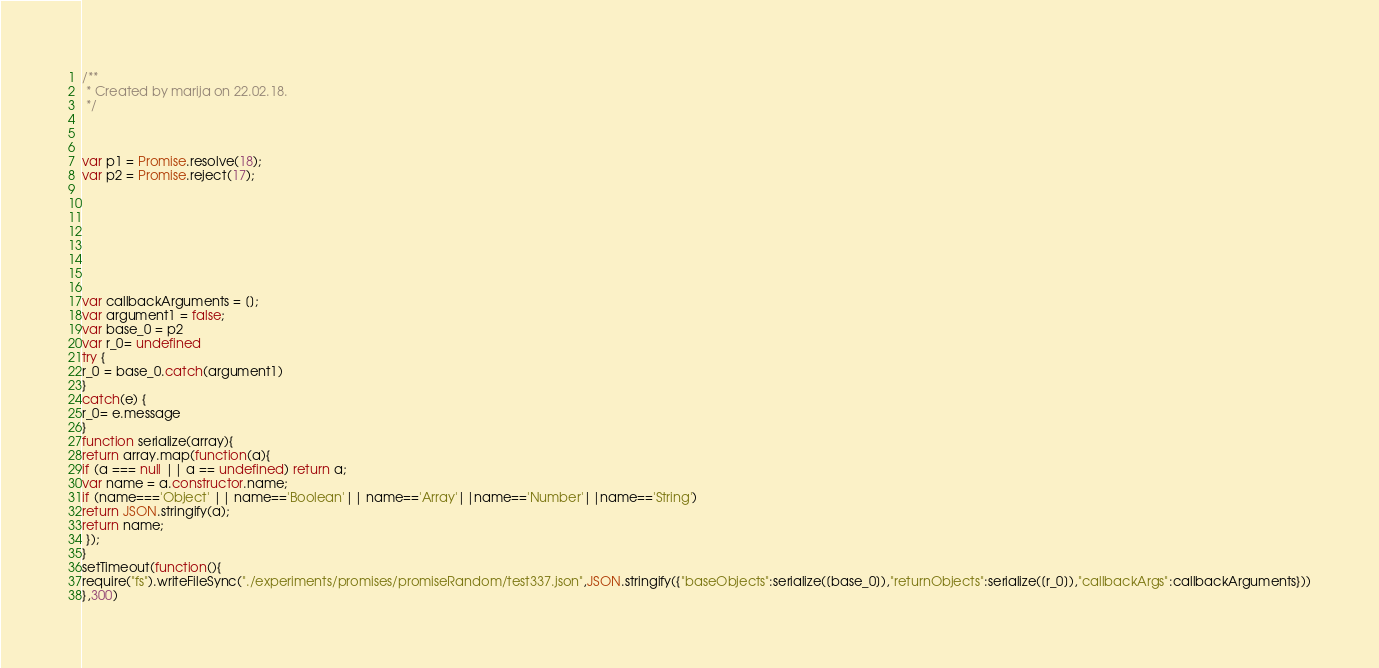<code> <loc_0><loc_0><loc_500><loc_500><_JavaScript_>/**
 * Created by marija on 22.02.18.
 */



var p1 = Promise.resolve(18);
var p2 = Promise.reject(17);








var callbackArguments = [];
var argument1 = false;
var base_0 = p2
var r_0= undefined
try {
r_0 = base_0.catch(argument1)
}
catch(e) {
r_0= e.message
}
function serialize(array){
return array.map(function(a){
if (a === null || a == undefined) return a;
var name = a.constructor.name;
if (name==='Object' || name=='Boolean'|| name=='Array'||name=='Number'||name=='String')
return JSON.stringify(a);
return name;
 });
}
setTimeout(function(){
require("fs").writeFileSync("./experiments/promises/promiseRandom/test337.json",JSON.stringify({"baseObjects":serialize([base_0]),"returnObjects":serialize([r_0]),"callbackArgs":callbackArguments}))
},300)</code> 